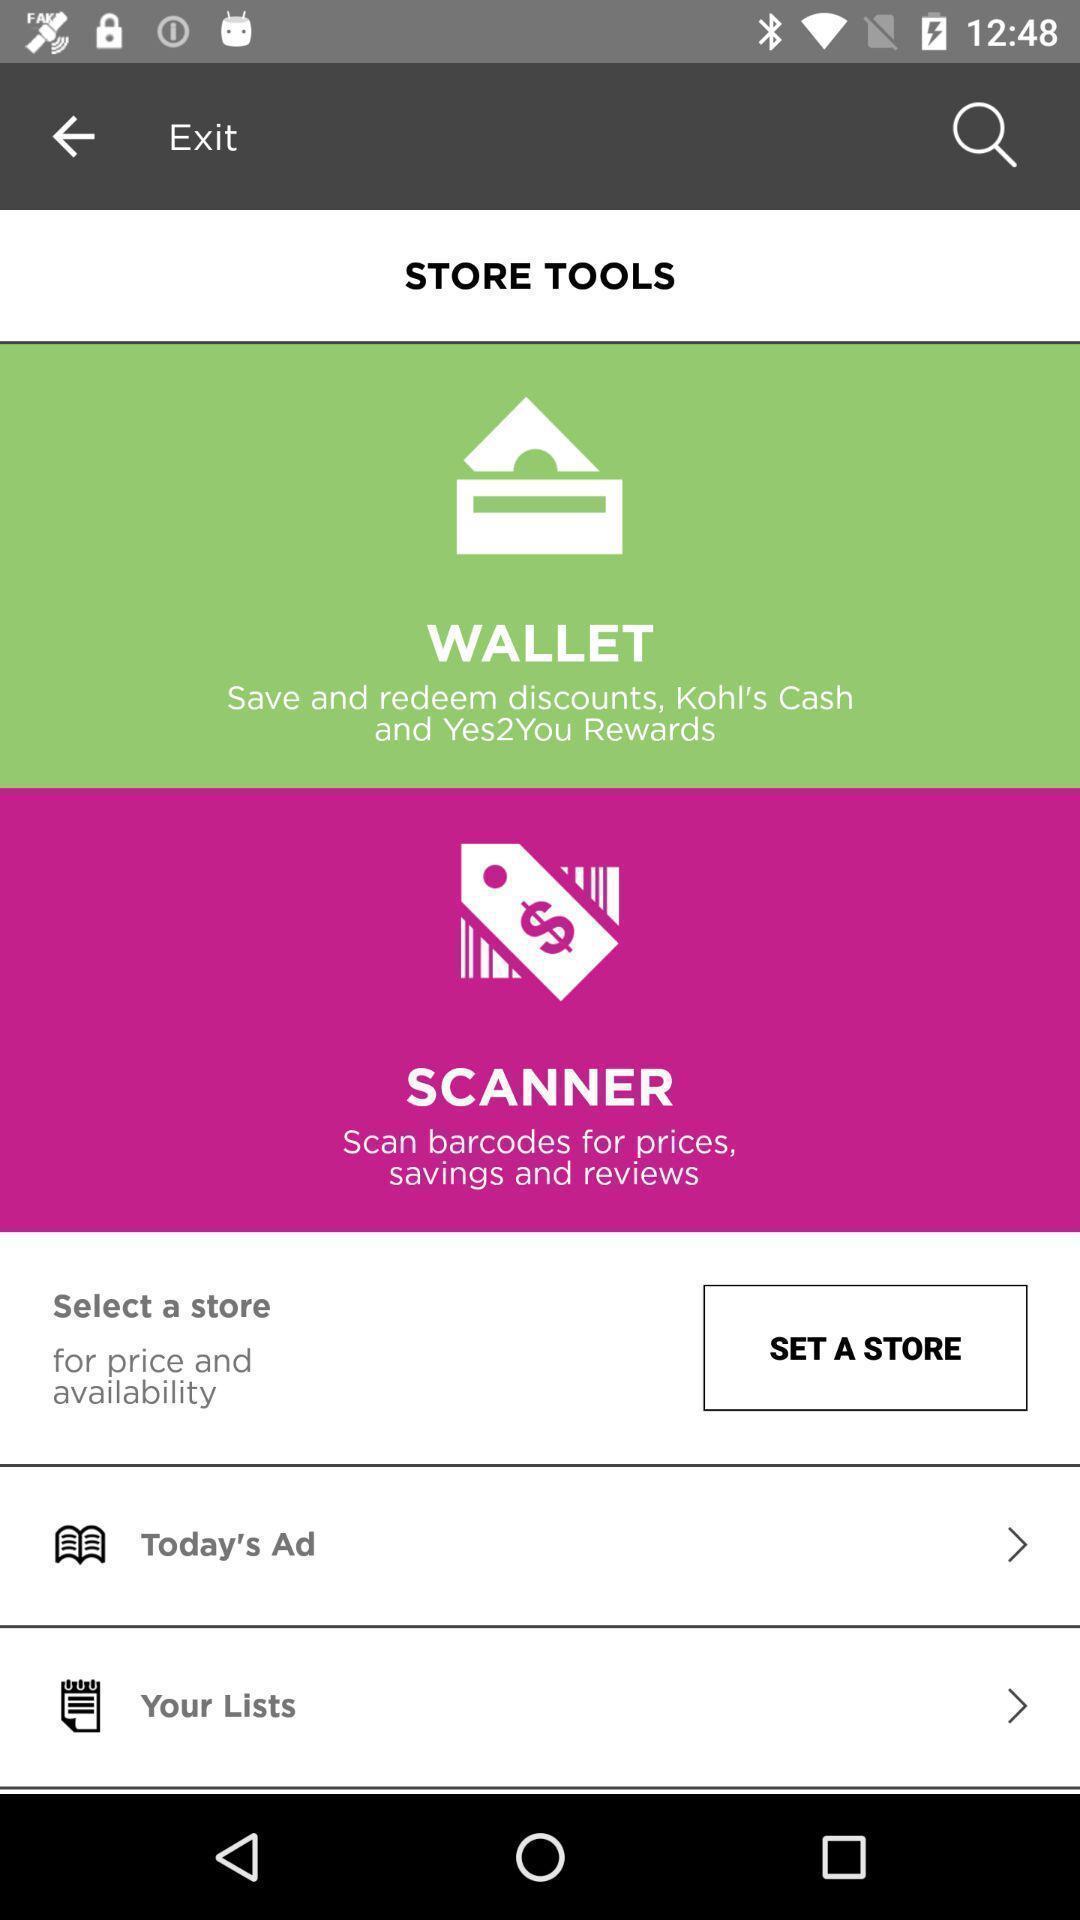What can you discern from this picture? Page is showing store tools with set a store option. 